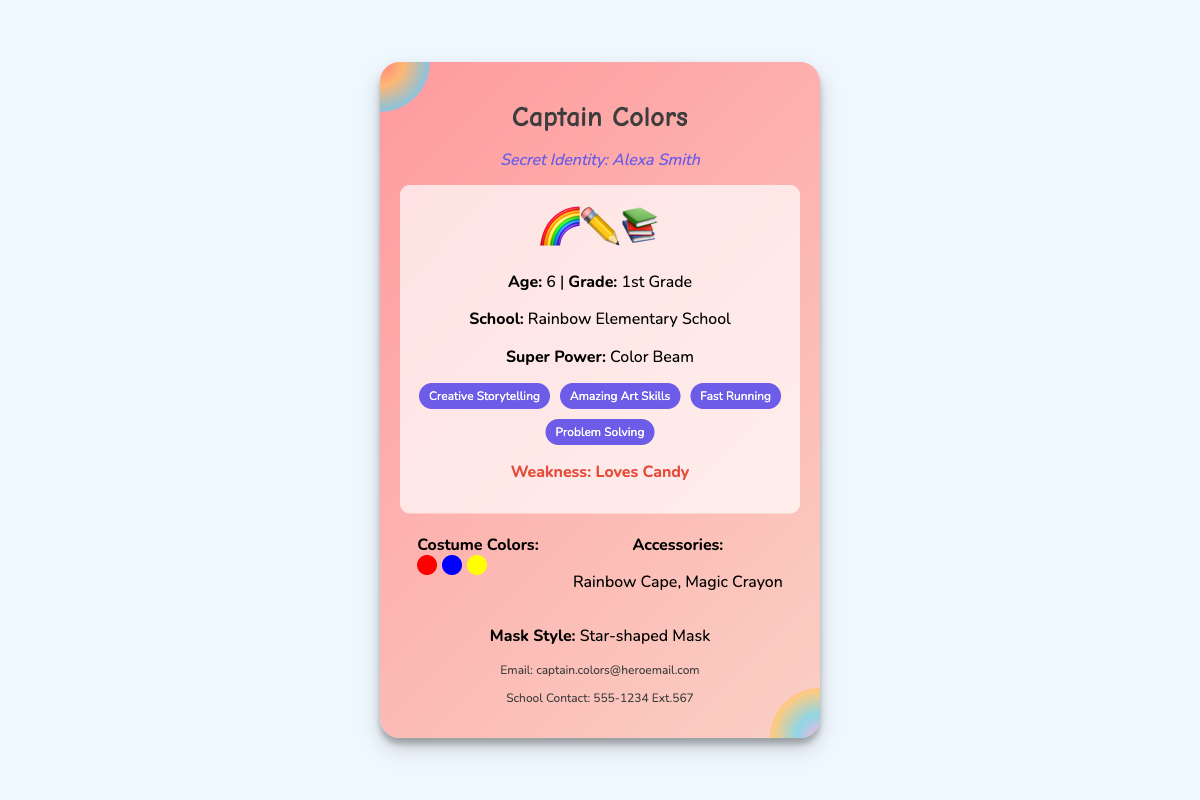What is the superhero's name? The superhero's name is found at the top of the card.
Answer: Captain Colors What is the secret identity of the superhero? The secret identity is mentioned below the superhero's name.
Answer: Alexa Smith How old is Captain Colors? The age is stated in the hero info section.
Answer: 6 What grade is Captain Colors in? The grade is listed with the age in the hero info section.
Answer: 1st Grade What is Captain Colors' super power? The super power is specified in the hero info section.
Answer: Color Beam What are the costume colors? The costume colors are mentioned in the appearance section with color dots.
Answer: Red, Blue, Yellow What accessories does Captain Colors have? The accessories are listed in the appearance section of the card.
Answer: Rainbow Cape, Magic Crayon What style is the mask? The mask style is described in the appearance section.
Answer: Star-shaped Mask What is the email address of Captain Colors? The email address is located in the contact info section of the card.
Answer: captain.colors@heroemail.com What is Captain Colors' weakness? The weakness is specified in the hero info section.
Answer: Loves Candy 